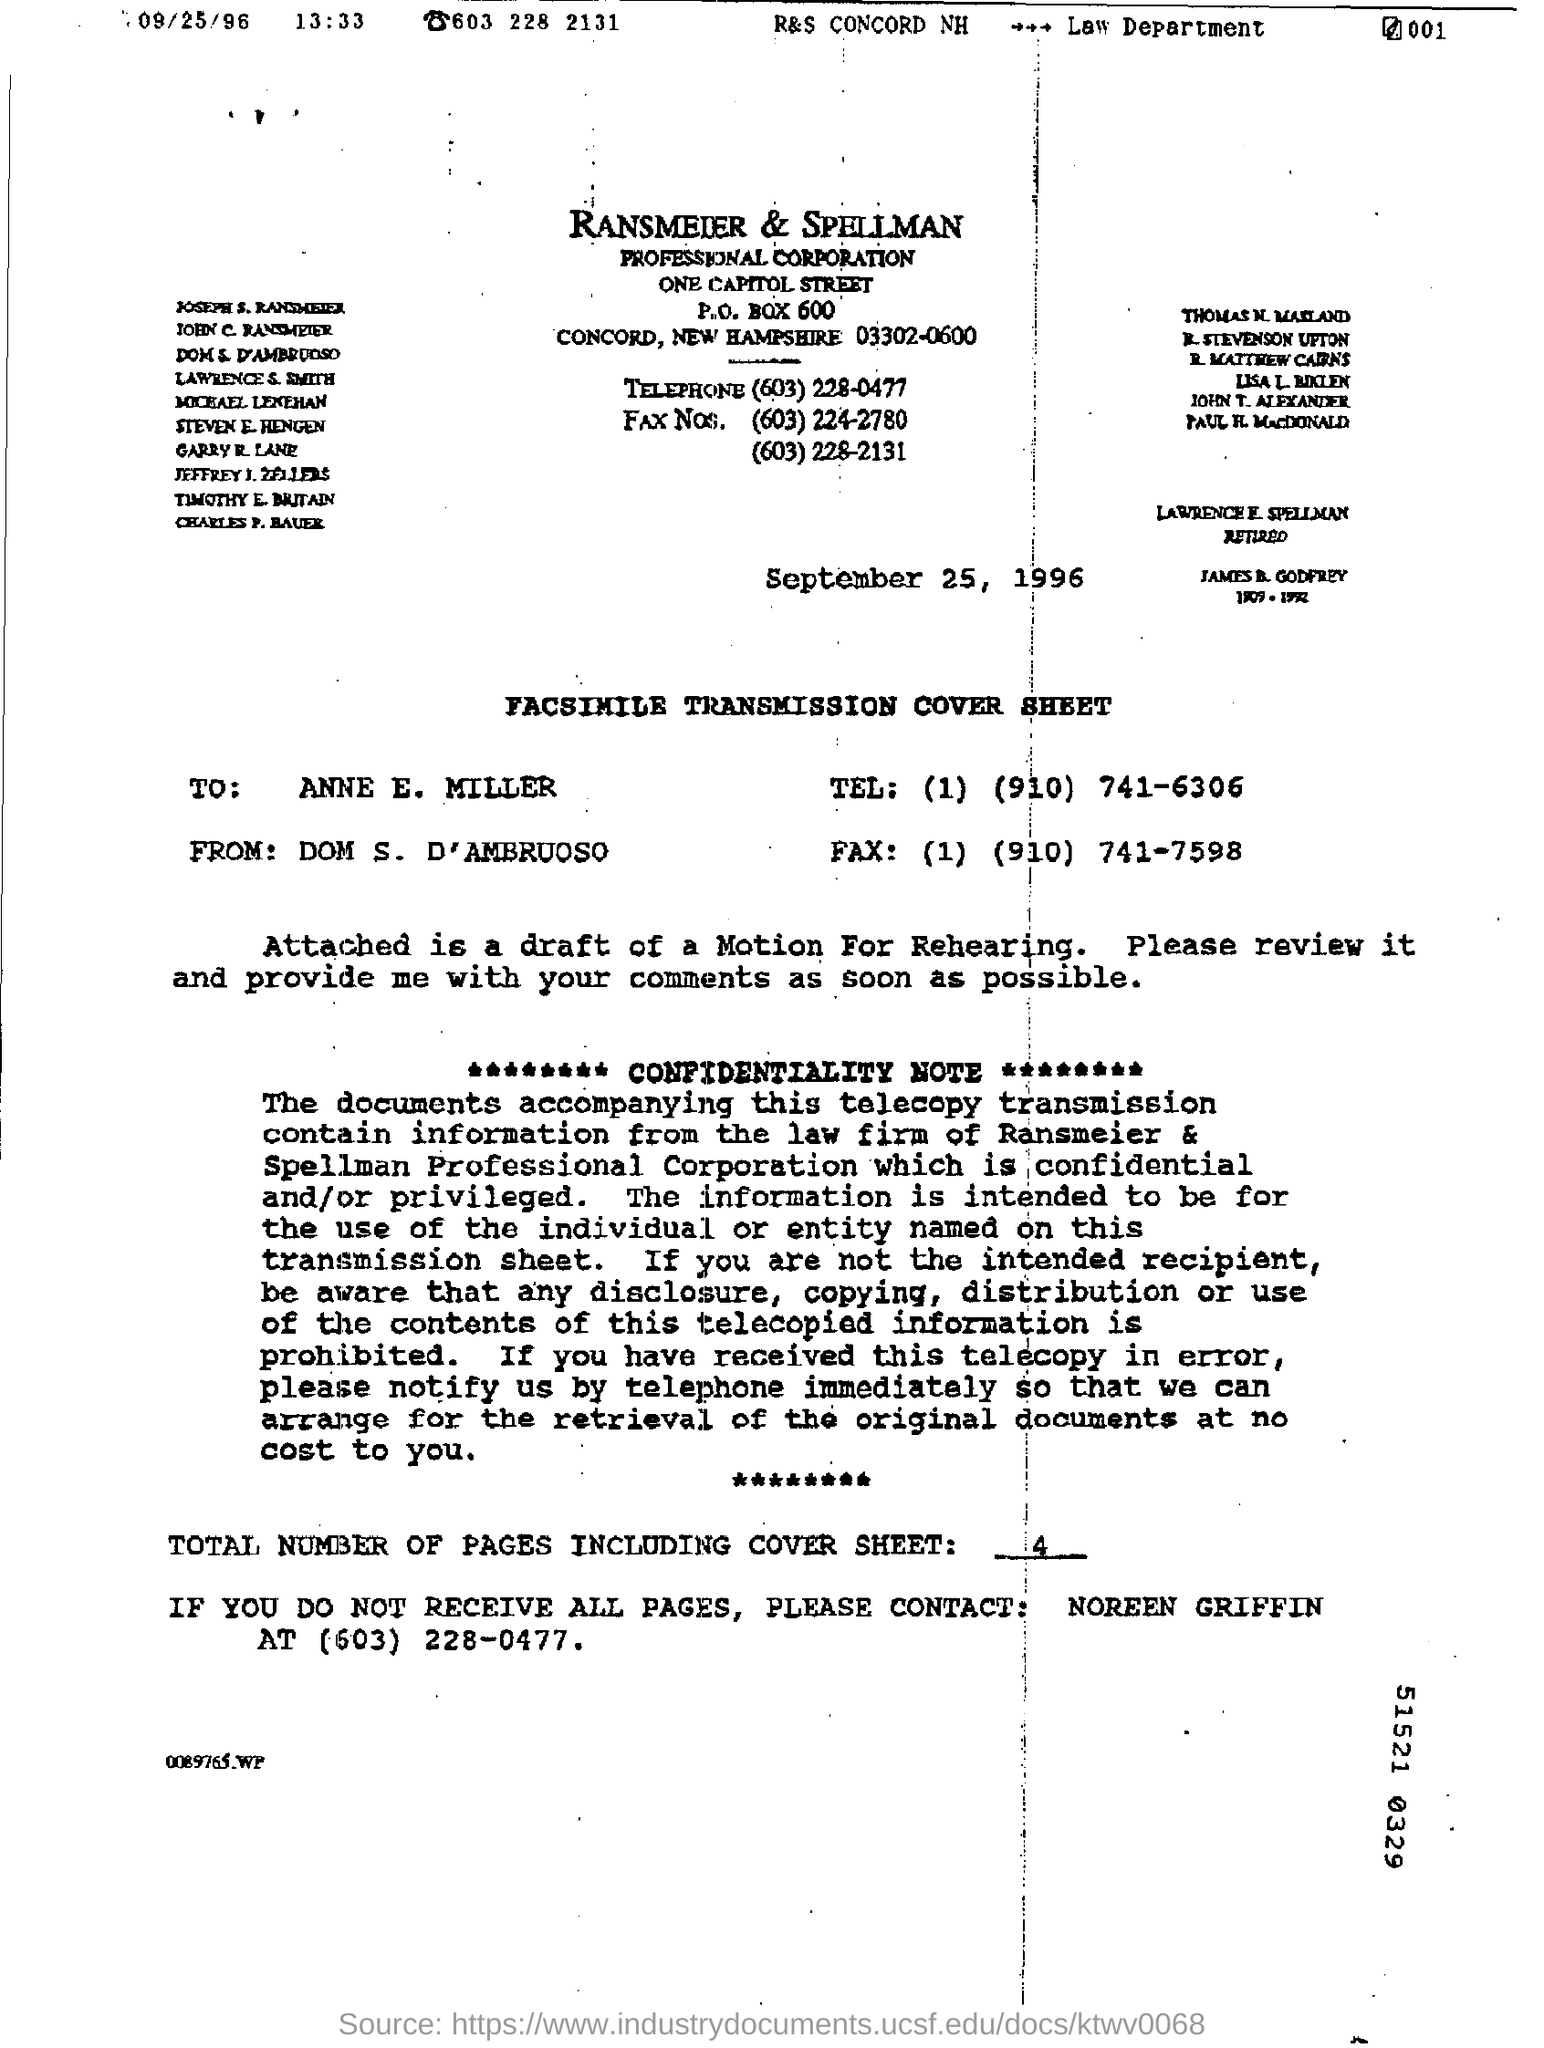Highlight a few significant elements in this photo. The total number of pages in the fax, including the cover sheet, is four. The recipient of the fax is Anne E. Miller.  DOM S. D'AMBRUOSO is the sender of the fax. 